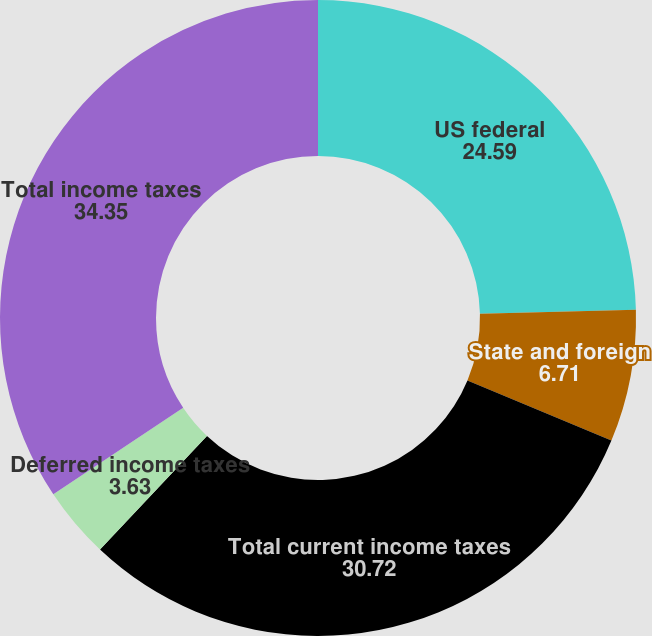Convert chart. <chart><loc_0><loc_0><loc_500><loc_500><pie_chart><fcel>US federal<fcel>State and foreign<fcel>Total current income taxes<fcel>Deferred income taxes<fcel>Total income taxes<nl><fcel>24.59%<fcel>6.71%<fcel>30.72%<fcel>3.63%<fcel>34.35%<nl></chart> 